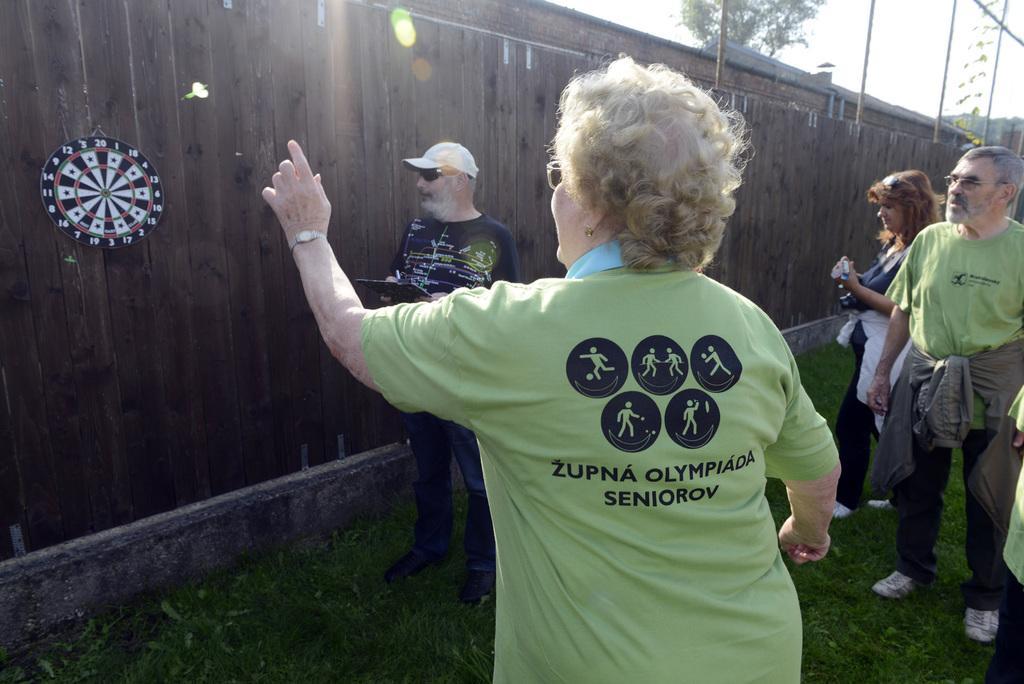Describe this image in one or two sentences. In this image there are people standing in front of a wooden wall, to that wall there is a board. 